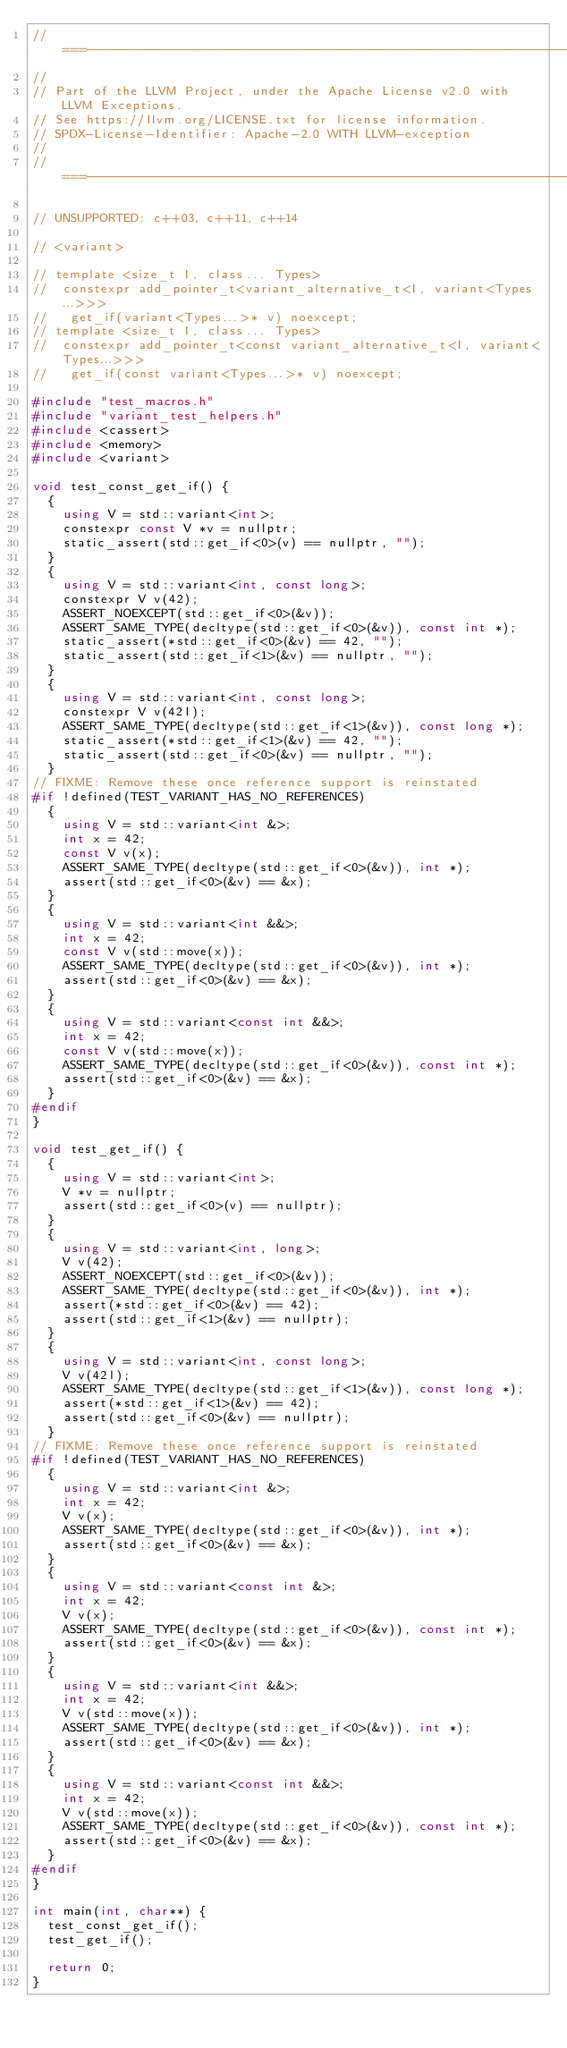Convert code to text. <code><loc_0><loc_0><loc_500><loc_500><_C++_>//===----------------------------------------------------------------------===//
//
// Part of the LLVM Project, under the Apache License v2.0 with LLVM Exceptions.
// See https://llvm.org/LICENSE.txt for license information.
// SPDX-License-Identifier: Apache-2.0 WITH LLVM-exception
//
//===----------------------------------------------------------------------===//

// UNSUPPORTED: c++03, c++11, c++14

// <variant>

// template <size_t I, class... Types>
//  constexpr add_pointer_t<variant_alternative_t<I, variant<Types...>>>
//   get_if(variant<Types...>* v) noexcept;
// template <size_t I, class... Types>
//  constexpr add_pointer_t<const variant_alternative_t<I, variant<Types...>>>
//   get_if(const variant<Types...>* v) noexcept;

#include "test_macros.h"
#include "variant_test_helpers.h"
#include <cassert>
#include <memory>
#include <variant>

void test_const_get_if() {
  {
    using V = std::variant<int>;
    constexpr const V *v = nullptr;
    static_assert(std::get_if<0>(v) == nullptr, "");
  }
  {
    using V = std::variant<int, const long>;
    constexpr V v(42);
    ASSERT_NOEXCEPT(std::get_if<0>(&v));
    ASSERT_SAME_TYPE(decltype(std::get_if<0>(&v)), const int *);
    static_assert(*std::get_if<0>(&v) == 42, "");
    static_assert(std::get_if<1>(&v) == nullptr, "");
  }
  {
    using V = std::variant<int, const long>;
    constexpr V v(42l);
    ASSERT_SAME_TYPE(decltype(std::get_if<1>(&v)), const long *);
    static_assert(*std::get_if<1>(&v) == 42, "");
    static_assert(std::get_if<0>(&v) == nullptr, "");
  }
// FIXME: Remove these once reference support is reinstated
#if !defined(TEST_VARIANT_HAS_NO_REFERENCES)
  {
    using V = std::variant<int &>;
    int x = 42;
    const V v(x);
    ASSERT_SAME_TYPE(decltype(std::get_if<0>(&v)), int *);
    assert(std::get_if<0>(&v) == &x);
  }
  {
    using V = std::variant<int &&>;
    int x = 42;
    const V v(std::move(x));
    ASSERT_SAME_TYPE(decltype(std::get_if<0>(&v)), int *);
    assert(std::get_if<0>(&v) == &x);
  }
  {
    using V = std::variant<const int &&>;
    int x = 42;
    const V v(std::move(x));
    ASSERT_SAME_TYPE(decltype(std::get_if<0>(&v)), const int *);
    assert(std::get_if<0>(&v) == &x);
  }
#endif
}

void test_get_if() {
  {
    using V = std::variant<int>;
    V *v = nullptr;
    assert(std::get_if<0>(v) == nullptr);
  }
  {
    using V = std::variant<int, long>;
    V v(42);
    ASSERT_NOEXCEPT(std::get_if<0>(&v));
    ASSERT_SAME_TYPE(decltype(std::get_if<0>(&v)), int *);
    assert(*std::get_if<0>(&v) == 42);
    assert(std::get_if<1>(&v) == nullptr);
  }
  {
    using V = std::variant<int, const long>;
    V v(42l);
    ASSERT_SAME_TYPE(decltype(std::get_if<1>(&v)), const long *);
    assert(*std::get_if<1>(&v) == 42);
    assert(std::get_if<0>(&v) == nullptr);
  }
// FIXME: Remove these once reference support is reinstated
#if !defined(TEST_VARIANT_HAS_NO_REFERENCES)
  {
    using V = std::variant<int &>;
    int x = 42;
    V v(x);
    ASSERT_SAME_TYPE(decltype(std::get_if<0>(&v)), int *);
    assert(std::get_if<0>(&v) == &x);
  }
  {
    using V = std::variant<const int &>;
    int x = 42;
    V v(x);
    ASSERT_SAME_TYPE(decltype(std::get_if<0>(&v)), const int *);
    assert(std::get_if<0>(&v) == &x);
  }
  {
    using V = std::variant<int &&>;
    int x = 42;
    V v(std::move(x));
    ASSERT_SAME_TYPE(decltype(std::get_if<0>(&v)), int *);
    assert(std::get_if<0>(&v) == &x);
  }
  {
    using V = std::variant<const int &&>;
    int x = 42;
    V v(std::move(x));
    ASSERT_SAME_TYPE(decltype(std::get_if<0>(&v)), const int *);
    assert(std::get_if<0>(&v) == &x);
  }
#endif
}

int main(int, char**) {
  test_const_get_if();
  test_get_if();

  return 0;
}
</code> 